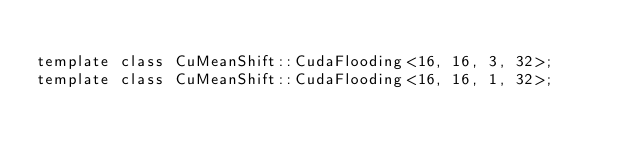<code> <loc_0><loc_0><loc_500><loc_500><_Cuda_>
template class CuMeanShift::CudaFlooding<16, 16, 3, 32>;
template class CuMeanShift::CudaFlooding<16, 16, 1, 32>;
</code> 